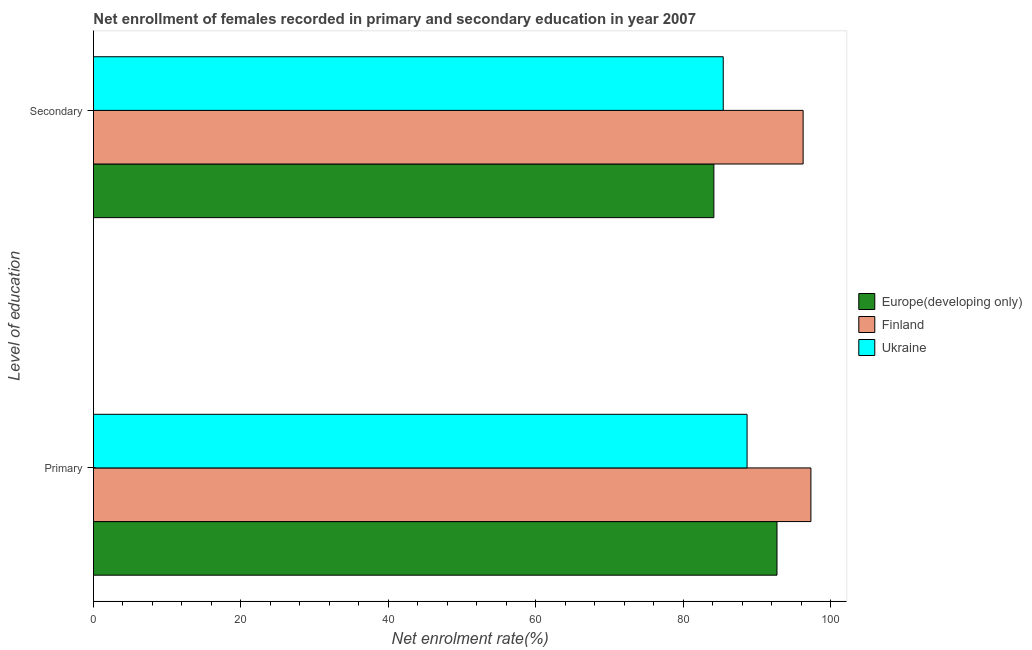How many groups of bars are there?
Your answer should be compact. 2. Are the number of bars per tick equal to the number of legend labels?
Make the answer very short. Yes. How many bars are there on the 1st tick from the bottom?
Provide a succinct answer. 3. What is the label of the 2nd group of bars from the top?
Offer a terse response. Primary. What is the enrollment rate in secondary education in Europe(developing only)?
Provide a succinct answer. 84.17. Across all countries, what is the maximum enrollment rate in primary education?
Provide a succinct answer. 97.34. Across all countries, what is the minimum enrollment rate in secondary education?
Ensure brevity in your answer.  84.17. In which country was the enrollment rate in secondary education minimum?
Your answer should be very brief. Europe(developing only). What is the total enrollment rate in secondary education in the graph?
Give a very brief answer. 265.9. What is the difference between the enrollment rate in primary education in Finland and that in Ukraine?
Your answer should be very brief. 8.66. What is the difference between the enrollment rate in primary education in Ukraine and the enrollment rate in secondary education in Finland?
Provide a short and direct response. -7.61. What is the average enrollment rate in primary education per country?
Ensure brevity in your answer.  92.92. What is the difference between the enrollment rate in primary education and enrollment rate in secondary education in Europe(developing only)?
Keep it short and to the point. 8.56. In how many countries, is the enrollment rate in primary education greater than 20 %?
Provide a short and direct response. 3. What is the ratio of the enrollment rate in primary education in Ukraine to that in Finland?
Provide a short and direct response. 0.91. Is the enrollment rate in primary education in Europe(developing only) less than that in Finland?
Offer a very short reply. Yes. What does the 3rd bar from the top in Secondary represents?
Your answer should be very brief. Europe(developing only). What does the 2nd bar from the bottom in Primary represents?
Give a very brief answer. Finland. How many bars are there?
Keep it short and to the point. 6. Are all the bars in the graph horizontal?
Make the answer very short. Yes. How many countries are there in the graph?
Provide a succinct answer. 3. Does the graph contain any zero values?
Give a very brief answer. No. Does the graph contain grids?
Make the answer very short. No. How many legend labels are there?
Provide a succinct answer. 3. What is the title of the graph?
Ensure brevity in your answer.  Net enrollment of females recorded in primary and secondary education in year 2007. Does "St. Vincent and the Grenadines" appear as one of the legend labels in the graph?
Your answer should be compact. No. What is the label or title of the X-axis?
Your response must be concise. Net enrolment rate(%). What is the label or title of the Y-axis?
Your answer should be compact. Level of education. What is the Net enrolment rate(%) of Europe(developing only) in Primary?
Provide a succinct answer. 92.74. What is the Net enrolment rate(%) of Finland in Primary?
Keep it short and to the point. 97.34. What is the Net enrolment rate(%) of Ukraine in Primary?
Offer a terse response. 88.68. What is the Net enrolment rate(%) of Europe(developing only) in Secondary?
Your answer should be very brief. 84.17. What is the Net enrolment rate(%) in Finland in Secondary?
Provide a succinct answer. 96.28. What is the Net enrolment rate(%) in Ukraine in Secondary?
Your answer should be compact. 85.44. Across all Level of education, what is the maximum Net enrolment rate(%) of Europe(developing only)?
Your response must be concise. 92.74. Across all Level of education, what is the maximum Net enrolment rate(%) in Finland?
Offer a very short reply. 97.34. Across all Level of education, what is the maximum Net enrolment rate(%) of Ukraine?
Make the answer very short. 88.68. Across all Level of education, what is the minimum Net enrolment rate(%) of Europe(developing only)?
Your answer should be compact. 84.17. Across all Level of education, what is the minimum Net enrolment rate(%) in Finland?
Make the answer very short. 96.28. Across all Level of education, what is the minimum Net enrolment rate(%) of Ukraine?
Offer a very short reply. 85.44. What is the total Net enrolment rate(%) in Europe(developing only) in the graph?
Offer a very short reply. 176.91. What is the total Net enrolment rate(%) in Finland in the graph?
Your answer should be very brief. 193.62. What is the total Net enrolment rate(%) in Ukraine in the graph?
Provide a succinct answer. 174.12. What is the difference between the Net enrolment rate(%) of Europe(developing only) in Primary and that in Secondary?
Give a very brief answer. 8.56. What is the difference between the Net enrolment rate(%) in Finland in Primary and that in Secondary?
Ensure brevity in your answer.  1.05. What is the difference between the Net enrolment rate(%) in Ukraine in Primary and that in Secondary?
Provide a short and direct response. 3.23. What is the difference between the Net enrolment rate(%) of Europe(developing only) in Primary and the Net enrolment rate(%) of Finland in Secondary?
Offer a terse response. -3.55. What is the difference between the Net enrolment rate(%) of Europe(developing only) in Primary and the Net enrolment rate(%) of Ukraine in Secondary?
Ensure brevity in your answer.  7.29. What is the difference between the Net enrolment rate(%) of Finland in Primary and the Net enrolment rate(%) of Ukraine in Secondary?
Your response must be concise. 11.89. What is the average Net enrolment rate(%) of Europe(developing only) per Level of education?
Provide a succinct answer. 88.45. What is the average Net enrolment rate(%) in Finland per Level of education?
Your response must be concise. 96.81. What is the average Net enrolment rate(%) in Ukraine per Level of education?
Provide a short and direct response. 87.06. What is the difference between the Net enrolment rate(%) in Europe(developing only) and Net enrolment rate(%) in Finland in Primary?
Your response must be concise. -4.6. What is the difference between the Net enrolment rate(%) in Europe(developing only) and Net enrolment rate(%) in Ukraine in Primary?
Your response must be concise. 4.06. What is the difference between the Net enrolment rate(%) in Finland and Net enrolment rate(%) in Ukraine in Primary?
Provide a short and direct response. 8.66. What is the difference between the Net enrolment rate(%) in Europe(developing only) and Net enrolment rate(%) in Finland in Secondary?
Your response must be concise. -12.11. What is the difference between the Net enrolment rate(%) in Europe(developing only) and Net enrolment rate(%) in Ukraine in Secondary?
Make the answer very short. -1.27. What is the difference between the Net enrolment rate(%) in Finland and Net enrolment rate(%) in Ukraine in Secondary?
Make the answer very short. 10.84. What is the ratio of the Net enrolment rate(%) in Europe(developing only) in Primary to that in Secondary?
Keep it short and to the point. 1.1. What is the ratio of the Net enrolment rate(%) in Ukraine in Primary to that in Secondary?
Make the answer very short. 1.04. What is the difference between the highest and the second highest Net enrolment rate(%) of Europe(developing only)?
Keep it short and to the point. 8.56. What is the difference between the highest and the second highest Net enrolment rate(%) in Finland?
Provide a short and direct response. 1.05. What is the difference between the highest and the second highest Net enrolment rate(%) of Ukraine?
Your answer should be very brief. 3.23. What is the difference between the highest and the lowest Net enrolment rate(%) of Europe(developing only)?
Provide a succinct answer. 8.56. What is the difference between the highest and the lowest Net enrolment rate(%) in Finland?
Offer a very short reply. 1.05. What is the difference between the highest and the lowest Net enrolment rate(%) in Ukraine?
Offer a terse response. 3.23. 